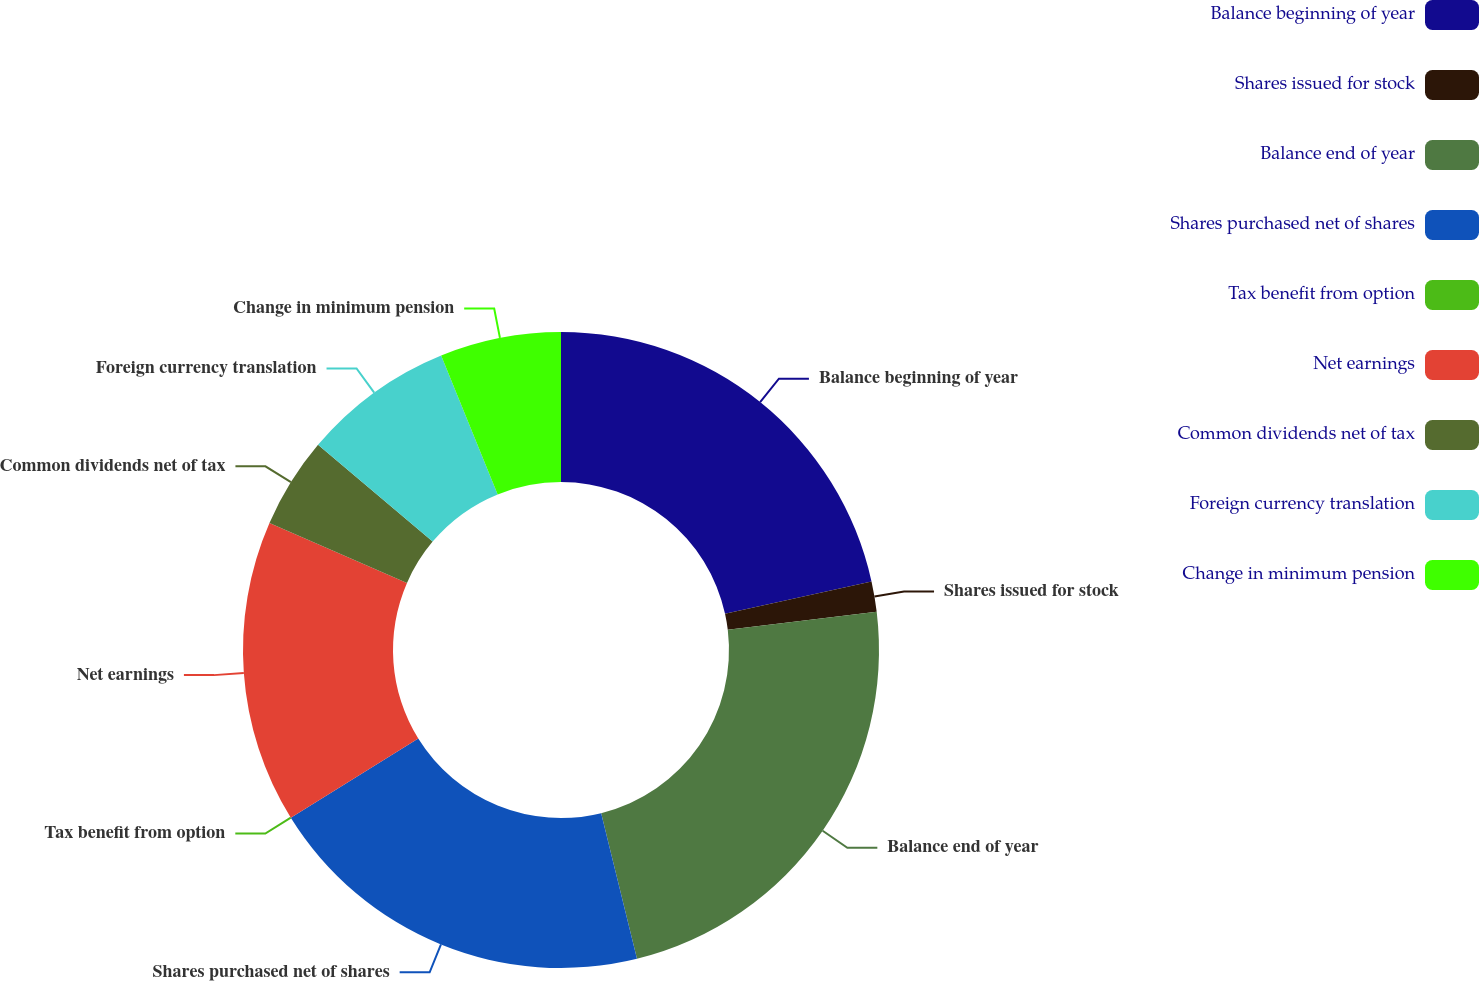Convert chart. <chart><loc_0><loc_0><loc_500><loc_500><pie_chart><fcel>Balance beginning of year<fcel>Shares issued for stock<fcel>Balance end of year<fcel>Shares purchased net of shares<fcel>Tax benefit from option<fcel>Net earnings<fcel>Common dividends net of tax<fcel>Foreign currency translation<fcel>Change in minimum pension<nl><fcel>21.54%<fcel>1.54%<fcel>23.08%<fcel>20.0%<fcel>0.0%<fcel>15.38%<fcel>4.62%<fcel>7.69%<fcel>6.15%<nl></chart> 